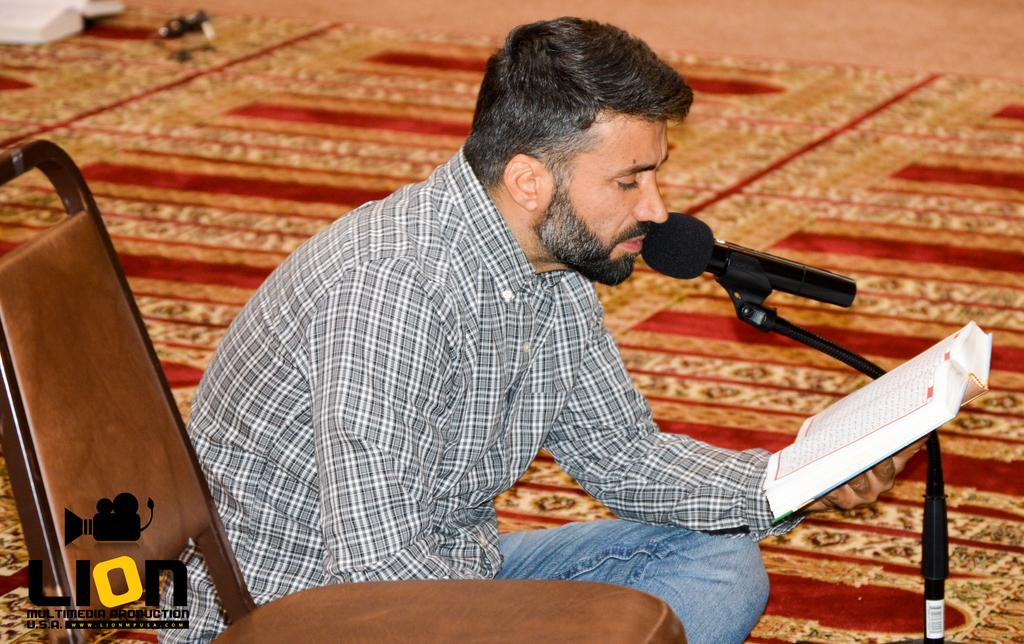What is the man in the image doing? The man is sitting on the floor in the image. What is the man holding in the image? The man is holding a book in the image. What piece of furniture is present in the image? There is a chair in the image. What type of equipment is visible in the image? There is a mic with a stand in the image. What else can be seen on the floor in the image? There is a book on the floor in the image. What type of snow can be seen falling in the image? There is no snow present in the image; it is an indoor setting with a man sitting on the floor, holding a book, and other objects. 